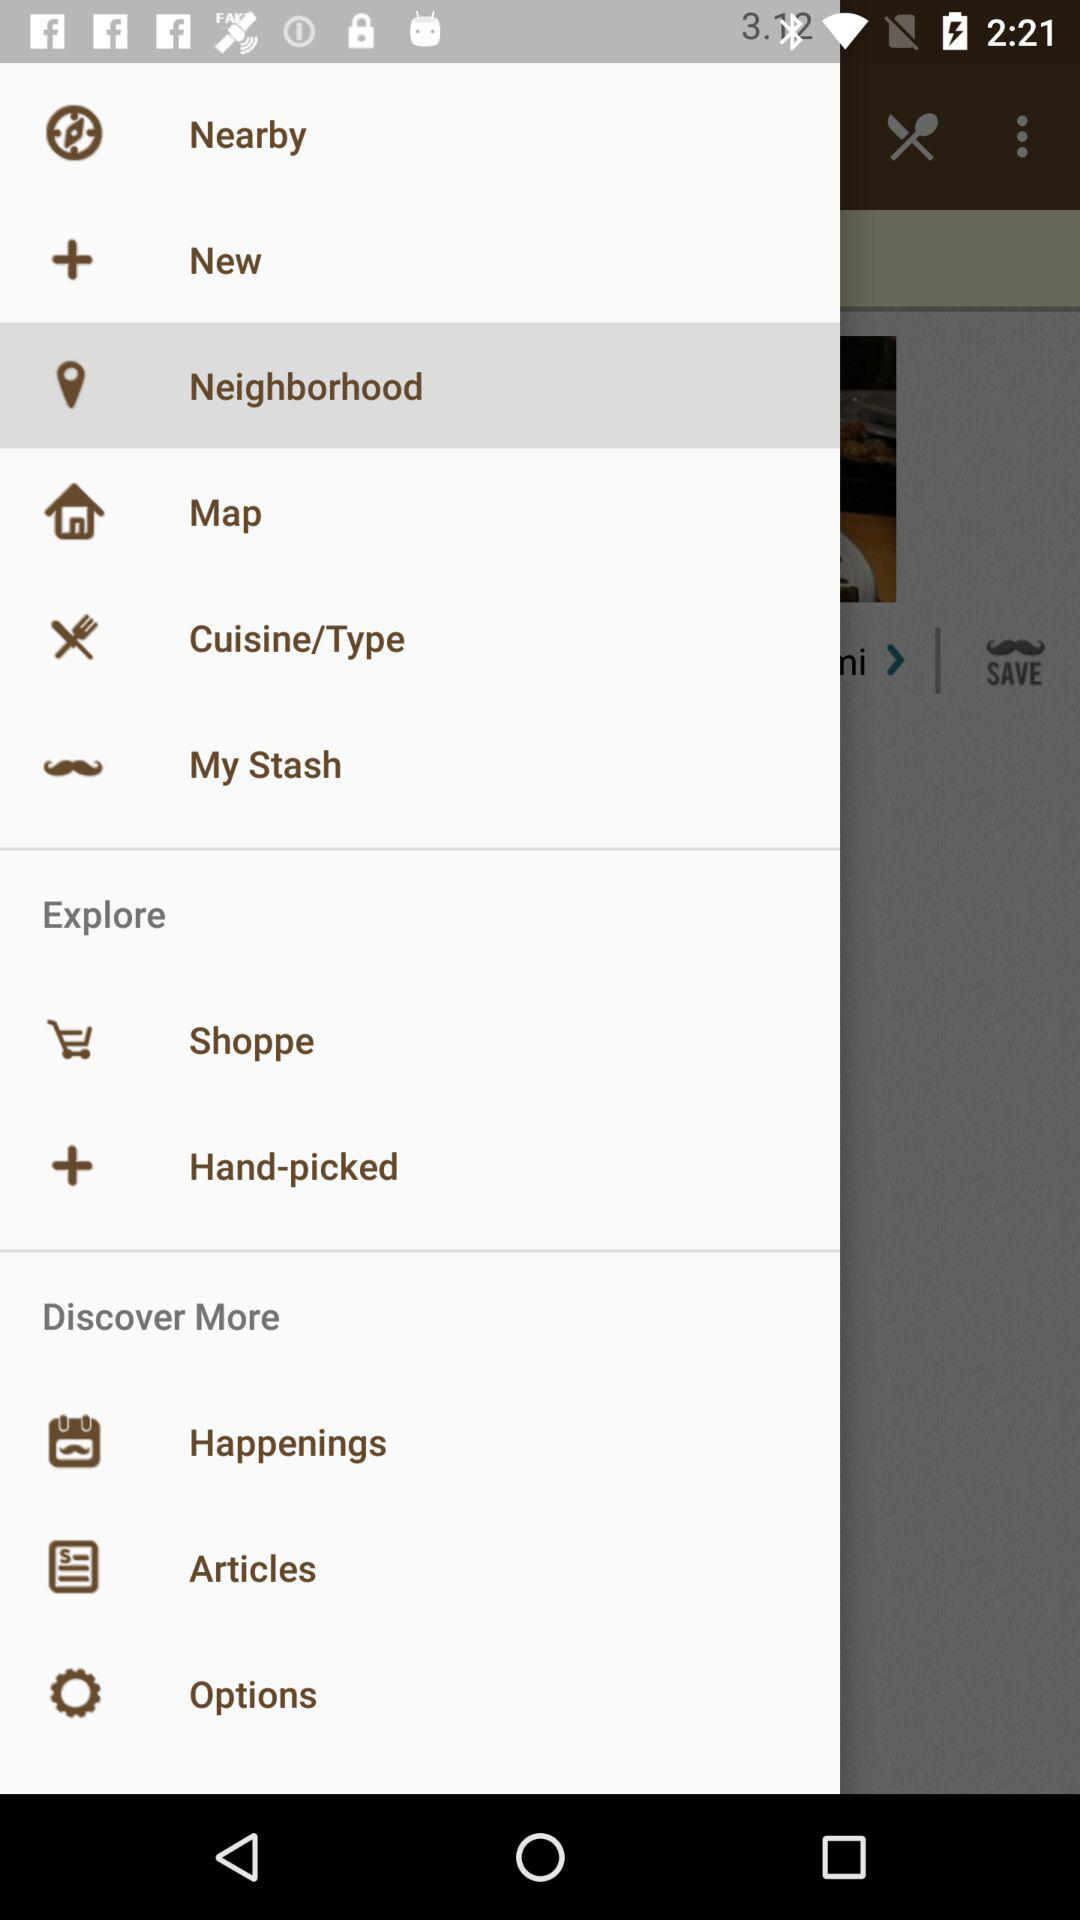What's the selected item in the menu? The selected item in the menu is "Neighborhood". 